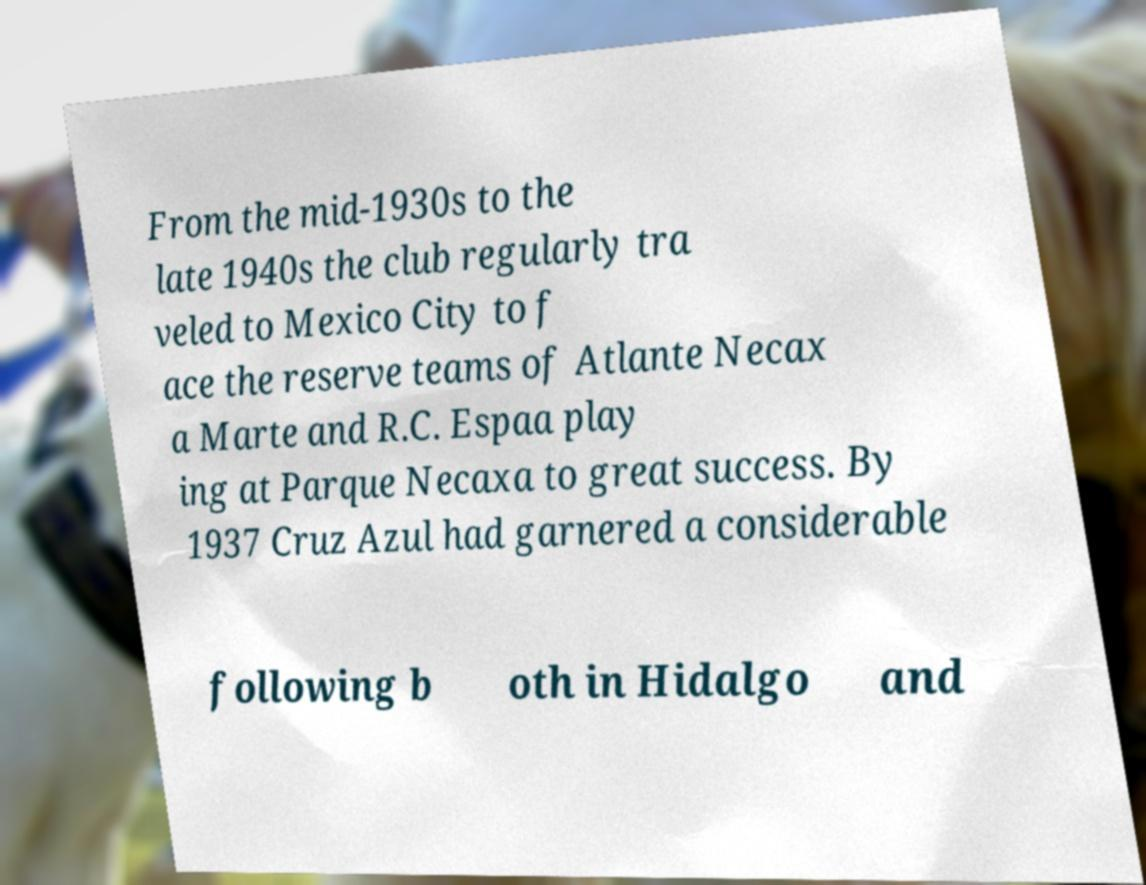Could you assist in decoding the text presented in this image and type it out clearly? From the mid-1930s to the late 1940s the club regularly tra veled to Mexico City to f ace the reserve teams of Atlante Necax a Marte and R.C. Espaa play ing at Parque Necaxa to great success. By 1937 Cruz Azul had garnered a considerable following b oth in Hidalgo and 